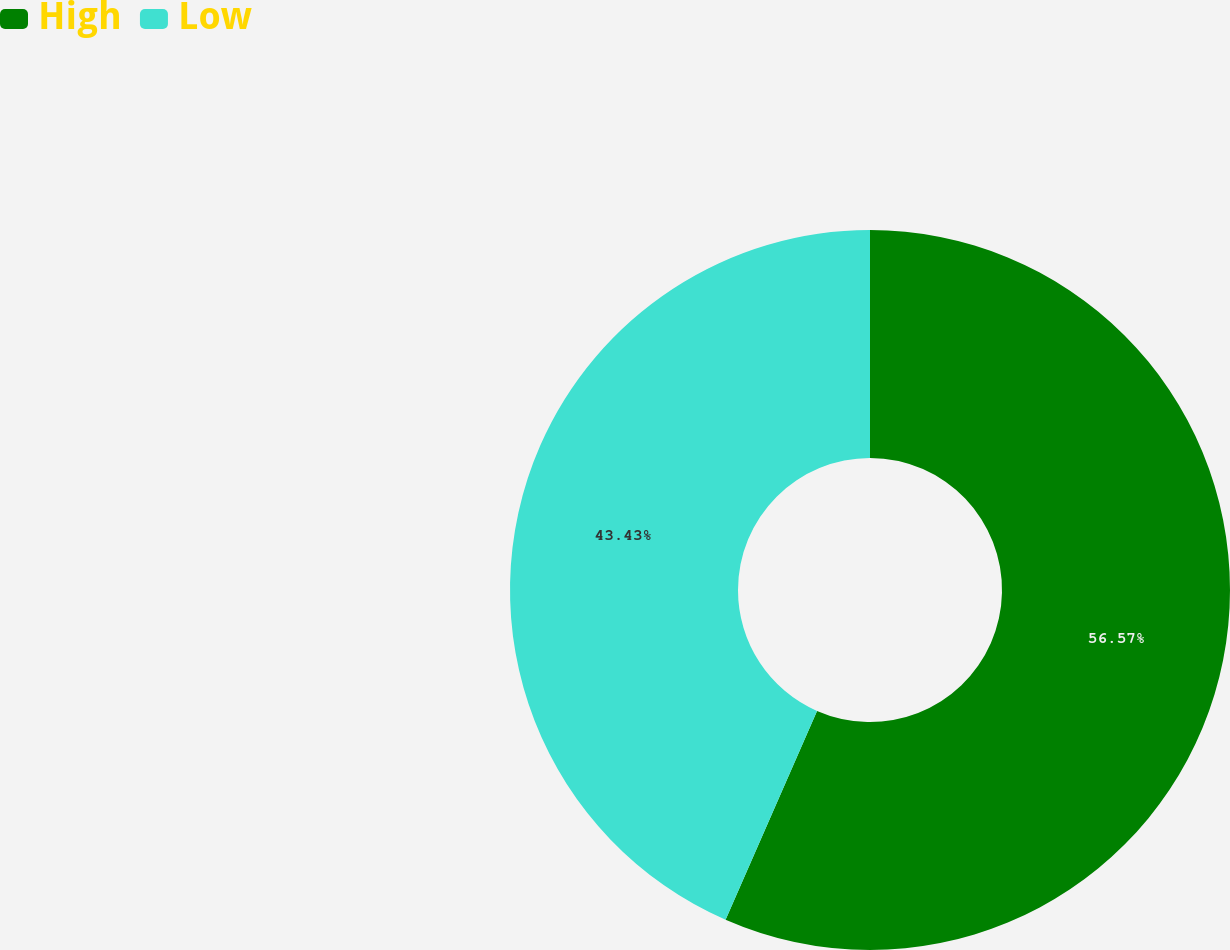Convert chart to OTSL. <chart><loc_0><loc_0><loc_500><loc_500><pie_chart><fcel>High<fcel>Low<nl><fcel>56.57%<fcel>43.43%<nl></chart> 